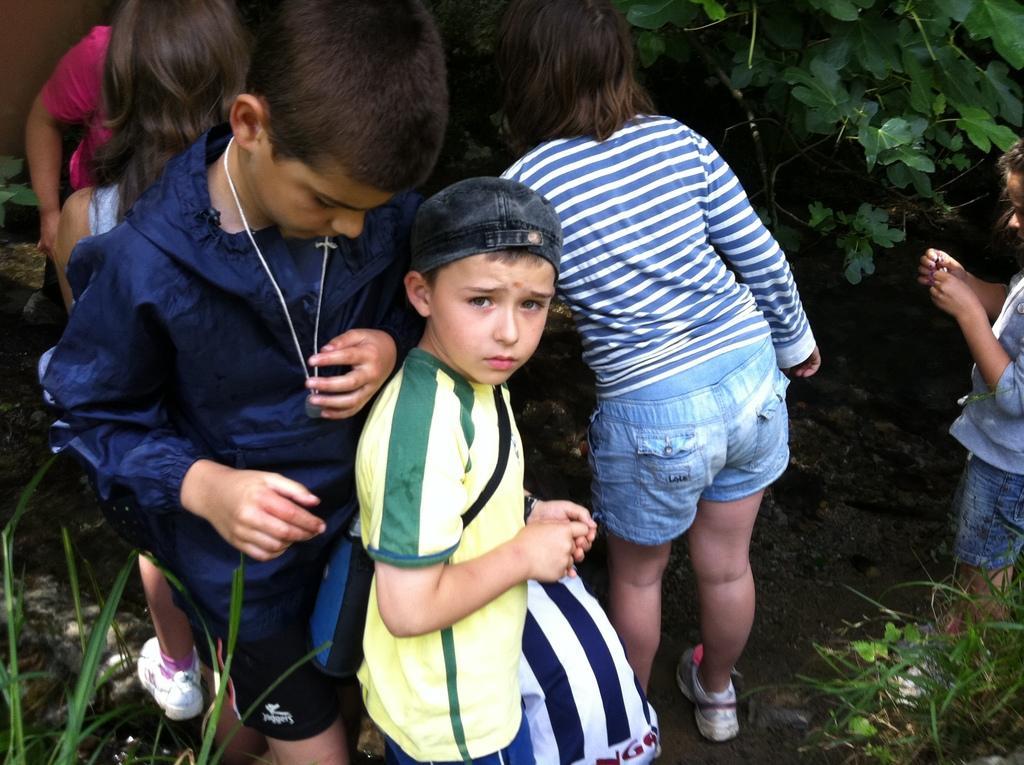In one or two sentences, can you explain what this image depicts? In this picture there are group of people standing. At the back there is a tree. At the bottom there is grass and mud. On the right side of the image there is a person standing and holding the object. 